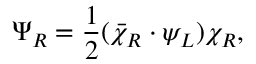Convert formula to latex. <formula><loc_0><loc_0><loc_500><loc_500>\Psi _ { R } = { \frac { 1 } { 2 } } ( \bar { \chi } _ { R } \cdot \psi _ { L } ) \chi _ { R } ,</formula> 